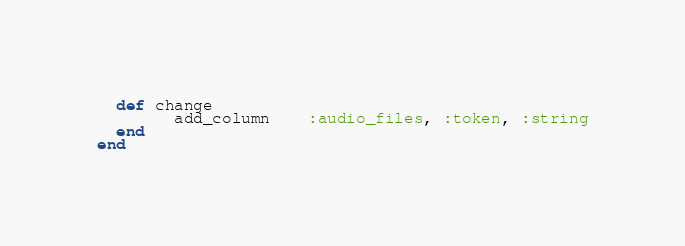<code> <loc_0><loc_0><loc_500><loc_500><_Ruby_>  def change
		add_column	:audio_files, :token, :string
  end
end
</code> 